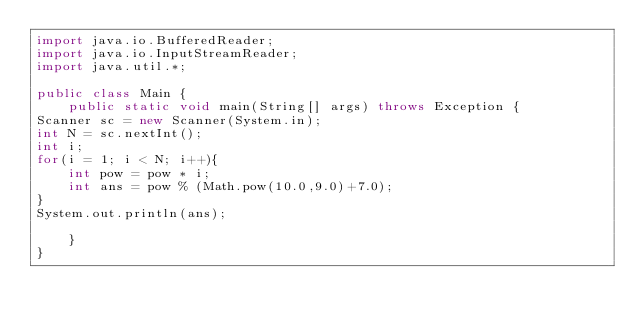<code> <loc_0><loc_0><loc_500><loc_500><_Java_>import java.io.BufferedReader;
import java.io.InputStreamReader;
import java.util.*;

public class Main {
    public static void main(String[] args) throws Exception {
Scanner sc = new Scanner(System.in);
int N = sc.nextInt();
int i;
for(i = 1; i < N; i++){
    int pow = pow * i;
    int ans = pow % (Math.pow(10.0,9.0)+7.0);
}
System.out.println(ans);

    }
}
</code> 